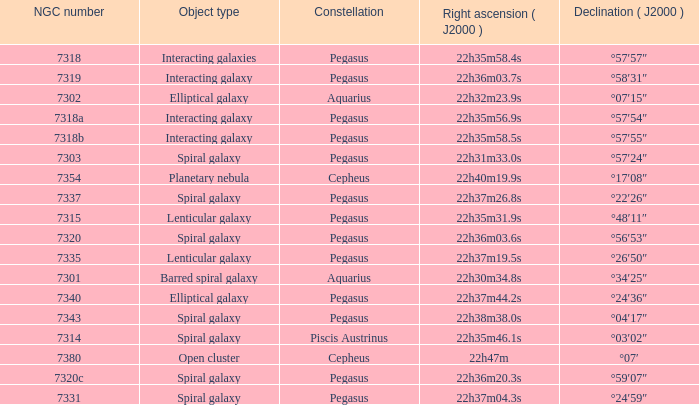What is the declination of the spiral galaxy Pegasus with 7337 NGC °22′26″. 